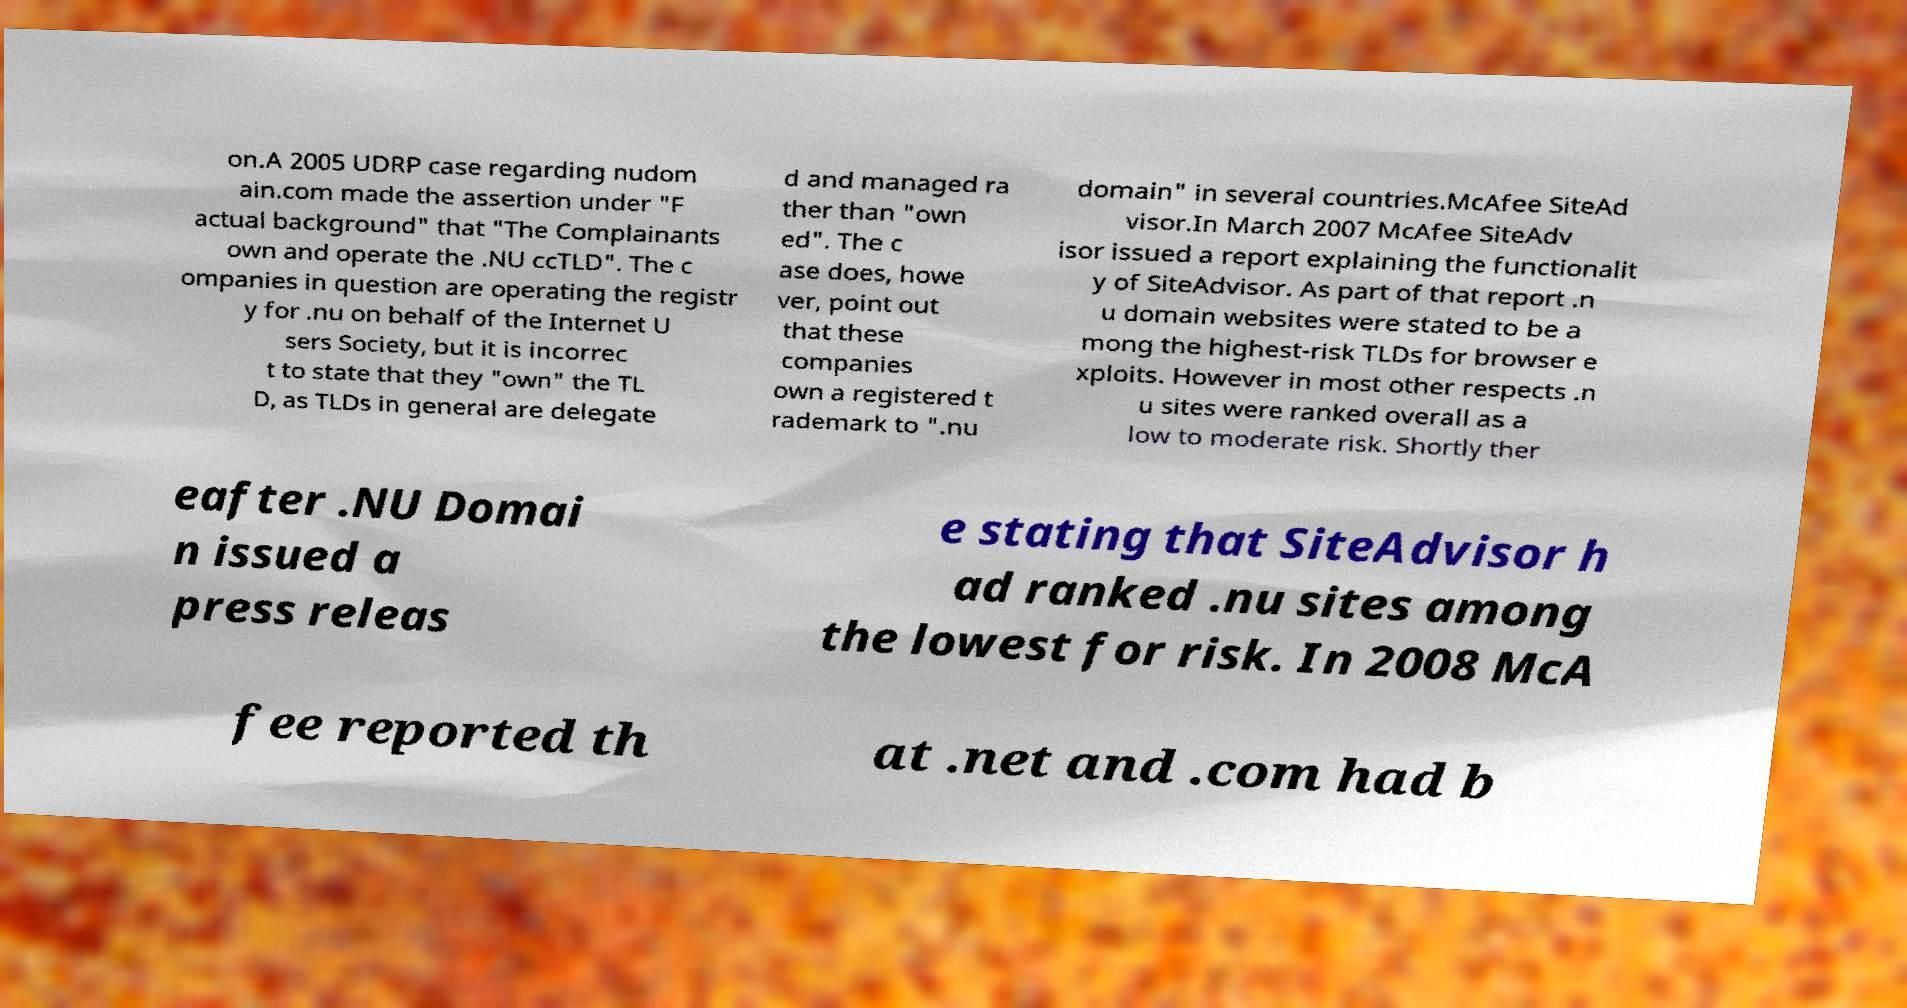Please identify and transcribe the text found in this image. on.A 2005 UDRP case regarding nudom ain.com made the assertion under "F actual background" that "The Complainants own and operate the .NU ccTLD". The c ompanies in question are operating the registr y for .nu on behalf of the Internet U sers Society, but it is incorrec t to state that they "own" the TL D, as TLDs in general are delegate d and managed ra ther than "own ed". The c ase does, howe ver, point out that these companies own a registered t rademark to ".nu domain" in several countries.McAfee SiteAd visor.In March 2007 McAfee SiteAdv isor issued a report explaining the functionalit y of SiteAdvisor. As part of that report .n u domain websites were stated to be a mong the highest-risk TLDs for browser e xploits. However in most other respects .n u sites were ranked overall as a low to moderate risk. Shortly ther eafter .NU Domai n issued a press releas e stating that SiteAdvisor h ad ranked .nu sites among the lowest for risk. In 2008 McA fee reported th at .net and .com had b 